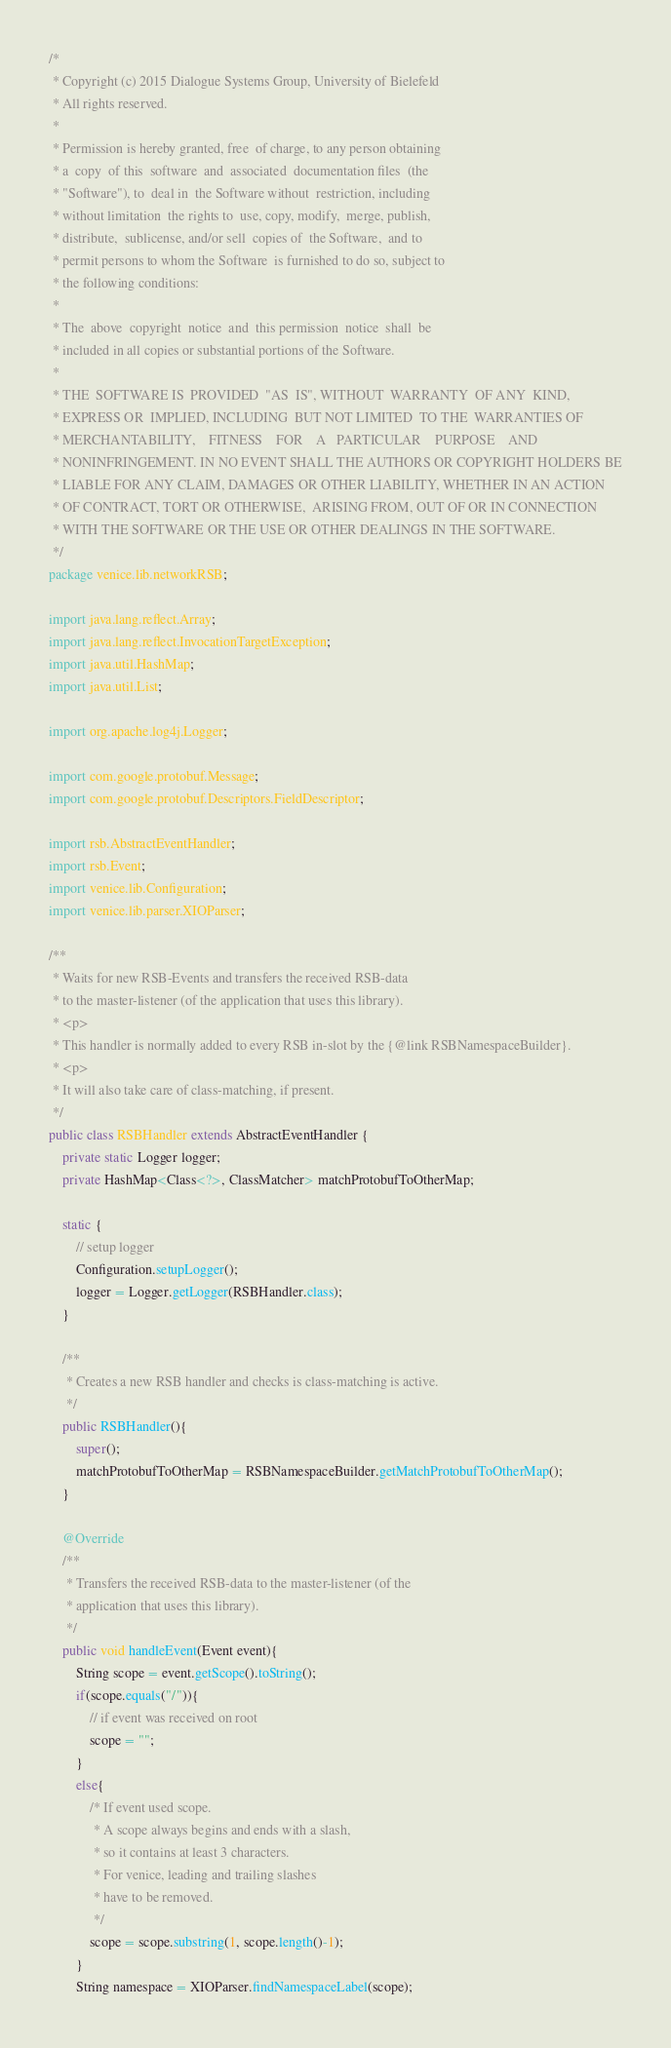<code> <loc_0><loc_0><loc_500><loc_500><_Java_>/*
 * Copyright (c) 2015 Dialogue Systems Group, University of Bielefeld
 * All rights reserved.
 *
 * Permission is hereby granted, free  of charge, to any person obtaining
 * a  copy  of this  software  and  associated  documentation files  (the
 * "Software"), to  deal in  the Software without  restriction, including
 * without limitation  the rights to  use, copy, modify,  merge, publish,
 * distribute,  sublicense, and/or sell  copies of  the Software,  and to
 * permit persons to whom the Software  is furnished to do so, subject to
 * the following conditions:
 *
 * The  above  copyright  notice  and  this permission  notice  shall  be
 * included in all copies or substantial portions of the Software.
 *
 * THE  SOFTWARE IS  PROVIDED  "AS  IS", WITHOUT  WARRANTY  OF ANY  KIND,
 * EXPRESS OR  IMPLIED, INCLUDING  BUT NOT LIMITED  TO THE  WARRANTIES OF
 * MERCHANTABILITY,    FITNESS    FOR    A   PARTICULAR    PURPOSE    AND
 * NONINFRINGEMENT. IN NO EVENT SHALL THE AUTHORS OR COPYRIGHT HOLDERS BE
 * LIABLE FOR ANY CLAIM, DAMAGES OR OTHER LIABILITY, WHETHER IN AN ACTION
 * OF CONTRACT, TORT OR OTHERWISE,  ARISING FROM, OUT OF OR IN CONNECTION
 * WITH THE SOFTWARE OR THE USE OR OTHER DEALINGS IN THE SOFTWARE.
 */
package venice.lib.networkRSB;

import java.lang.reflect.Array;
import java.lang.reflect.InvocationTargetException;
import java.util.HashMap;
import java.util.List;

import org.apache.log4j.Logger;

import com.google.protobuf.Message;
import com.google.protobuf.Descriptors.FieldDescriptor;

import rsb.AbstractEventHandler;
import rsb.Event;
import venice.lib.Configuration;
import venice.lib.parser.XIOParser;

/**
 * Waits for new RSB-Events and transfers the received RSB-data
 * to the master-listener (of the application that uses this library).
 * <p>
 * This handler is normally added to every RSB in-slot by the {@link RSBNamespaceBuilder}.
 * <p>
 * It will also take care of class-matching, if present.
 */
public class RSBHandler extends AbstractEventHandler {
	private static Logger logger;
	private HashMap<Class<?>, ClassMatcher> matchProtobufToOtherMap;
	
	static {
		// setup logger
		Configuration.setupLogger();
		logger = Logger.getLogger(RSBHandler.class);
	}
	
	/**
	 * Creates a new RSB handler and checks is class-matching is active.
	 */
	public RSBHandler(){
		super();
		matchProtobufToOtherMap = RSBNamespaceBuilder.getMatchProtobufToOtherMap();
	}

	@Override
	/**
	 * Transfers the received RSB-data to the master-listener (of the
	 * application that uses this library).
	 */
	public void handleEvent(Event event){
		String scope = event.getScope().toString();
		if(scope.equals("/")){
			// if event was received on root
			scope = "";
		}
		else{
			/* If event used scope.
			 * A scope always begins and ends with a slash,
			 * so it contains at least 3 characters.
			 * For venice, leading and trailing slashes
			 * have to be removed.
			 */
			scope = scope.substring(1, scope.length()-1);
		}
		String namespace = XIOParser.findNamespaceLabel(scope);</code> 